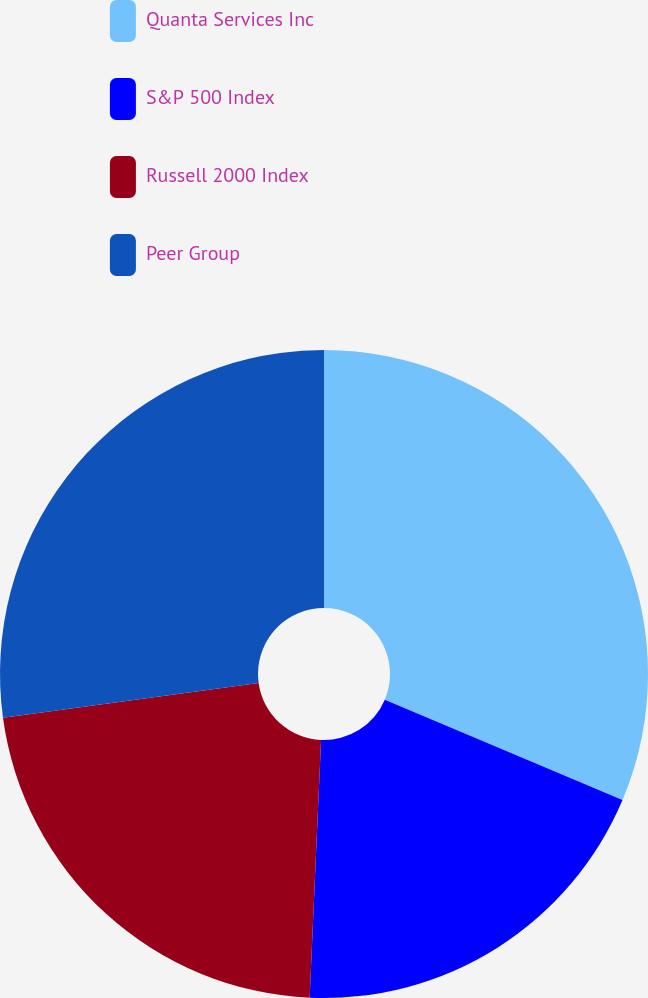<chart> <loc_0><loc_0><loc_500><loc_500><pie_chart><fcel>Quanta Services Inc<fcel>S&P 500 Index<fcel>Russell 2000 Index<fcel>Peer Group<nl><fcel>31.36%<fcel>19.35%<fcel>22.14%<fcel>27.16%<nl></chart> 